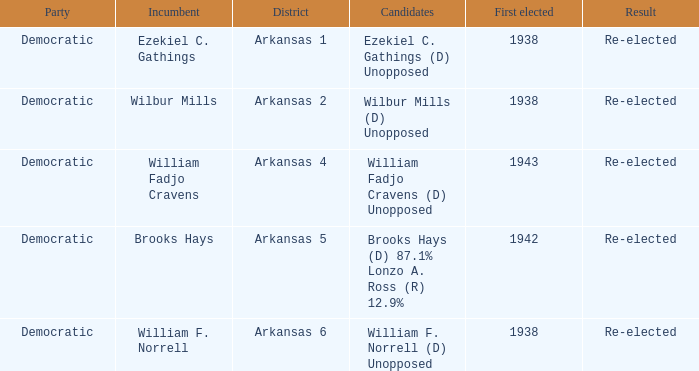What party did the incumbent from the Arkansas 5 district belong to?  Democratic. 